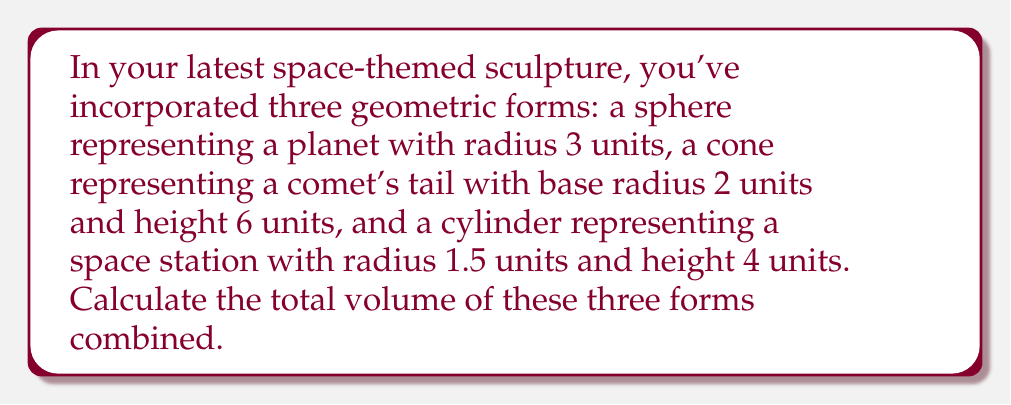Help me with this question. Let's calculate the volume of each geometric form separately and then sum them up:

1. Volume of the sphere (planet):
   The formula for the volume of a sphere is $V_s = \frac{4}{3}\pi r^3$
   $$V_s = \frac{4}{3}\pi (3)^3 = \frac{4}{3}\pi (27) = 36\pi$$

2. Volume of the cone (comet's tail):
   The formula for the volume of a cone is $V_c = \frac{1}{3}\pi r^2 h$
   $$V_c = \frac{1}{3}\pi (2)^2 (6) = \frac{1}{3}\pi (4) (6) = 8\pi$$

3. Volume of the cylinder (space station):
   The formula for the volume of a cylinder is $V_{cy} = \pi r^2 h$
   $$V_{cy} = \pi (1.5)^2 (4) = \pi (2.25) (4) = 9\pi$$

Now, let's sum up the volumes:
$$V_{total} = V_s + V_c + V_{cy} = 36\pi + 8\pi + 9\pi = 53\pi$$

Therefore, the total volume of all three geometric forms combined is $53\pi$ cubic units.
Answer: $53\pi$ cubic units 